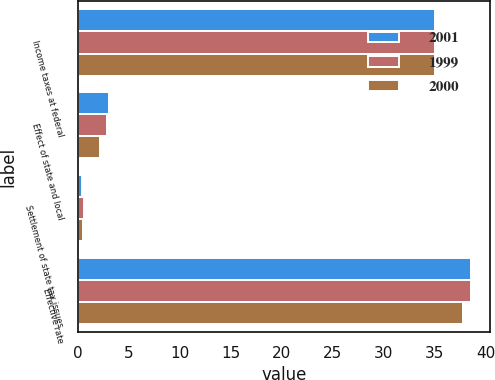Convert chart to OTSL. <chart><loc_0><loc_0><loc_500><loc_500><stacked_bar_chart><ecel><fcel>Income taxes at federal<fcel>Effect of state and local<fcel>Settlement of state tax issues<fcel>Effective rate<nl><fcel>2001<fcel>35<fcel>3.09<fcel>0.41<fcel>38.5<nl><fcel>1999<fcel>35<fcel>2.91<fcel>0.59<fcel>38.5<nl><fcel>2000<fcel>35<fcel>2.23<fcel>0.52<fcel>37.75<nl></chart> 